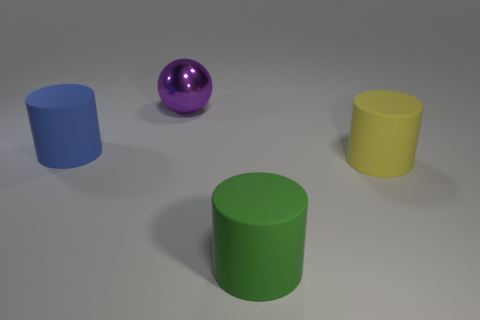What material is the ball that is the same size as the blue matte thing?
Give a very brief answer. Metal. There is a yellow matte object that is the same shape as the big green matte thing; what size is it?
Ensure brevity in your answer.  Large. How many things are either big blue cylinders or large matte cylinders that are in front of the big yellow cylinder?
Ensure brevity in your answer.  2. What shape is the yellow matte object?
Provide a succinct answer. Cylinder. The thing that is behind the rubber object on the left side of the large sphere is what shape?
Provide a succinct answer. Sphere. Are there more things that are to the right of the green object than big yellow matte cylinders in front of the large yellow rubber cylinder?
Give a very brief answer. Yes. Is there anything else that is the same shape as the large shiny object?
Keep it short and to the point. No. There is a big yellow object; does it have the same shape as the large thing on the left side of the shiny object?
Ensure brevity in your answer.  Yes. What number of other objects are the same material as the large yellow object?
Make the answer very short. 2. There is a big shiny ball; is its color the same as the large cylinder on the left side of the large metallic thing?
Provide a succinct answer. No. 